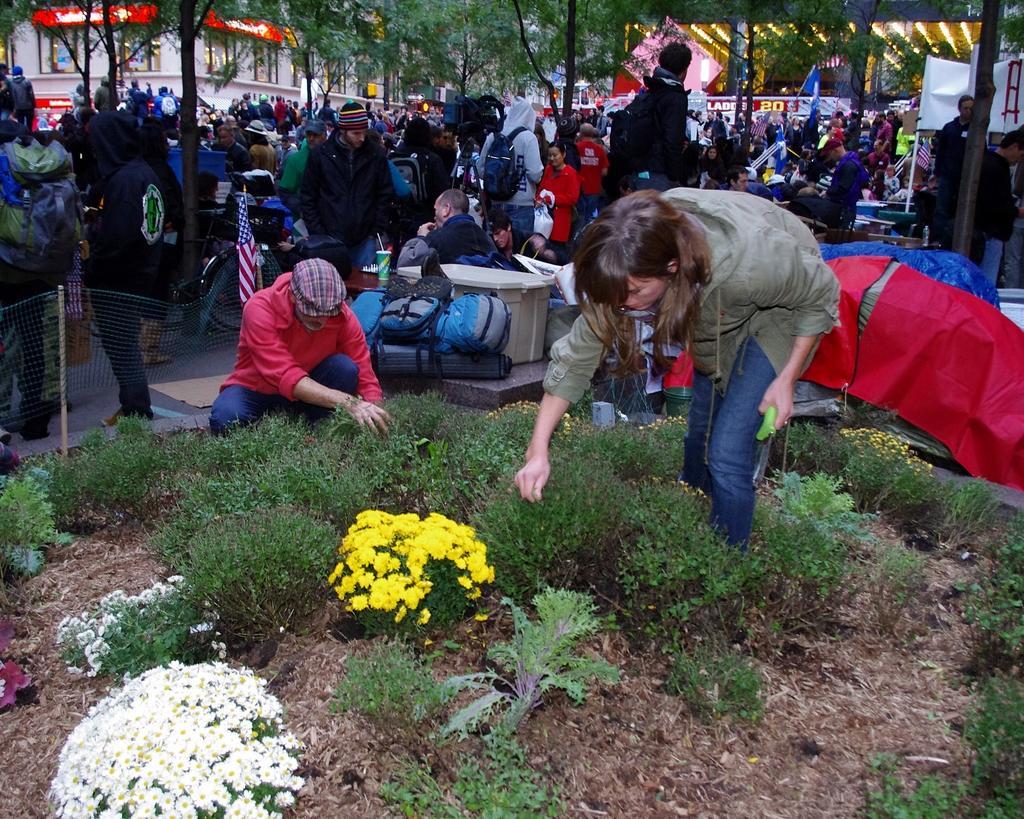How would you summarize this image in a sentence or two? In this picture, we can see a few people, and a few on the ground, we can see the ground with plants, flowers, trees, poles, fencing, poster with some text, bags, lights, flags, and some objects on the left side of the picture. 